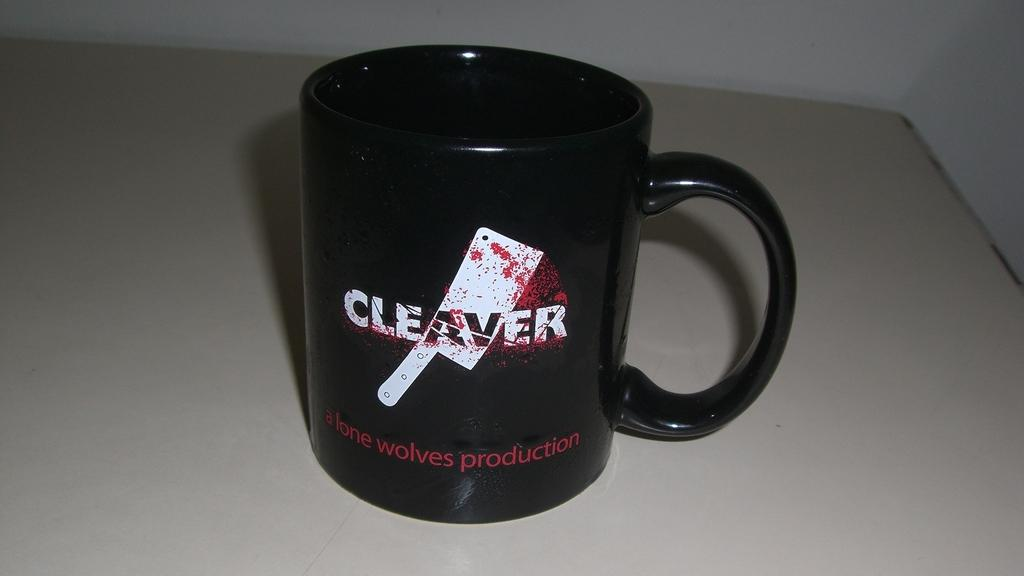<image>
Write a terse but informative summary of the picture. A black bug with cleaver written on it. 